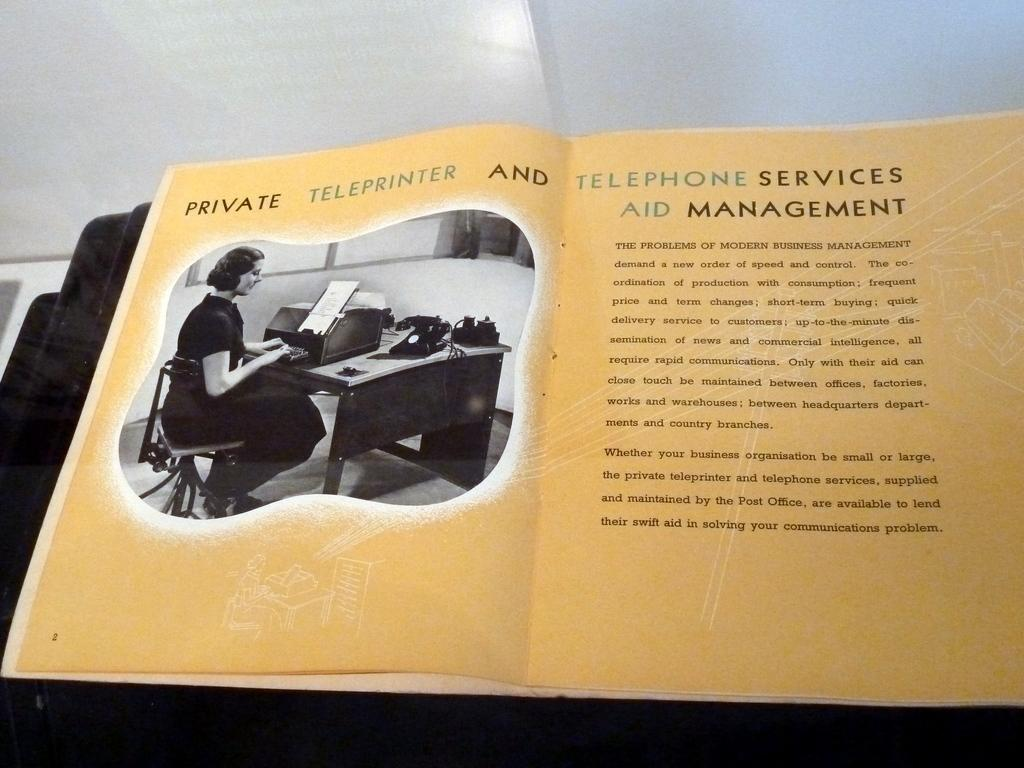<image>
Summarize the visual content of the image. A book opened to a page with the title "Private Teleprinter and Telephone Services Aid Management" 